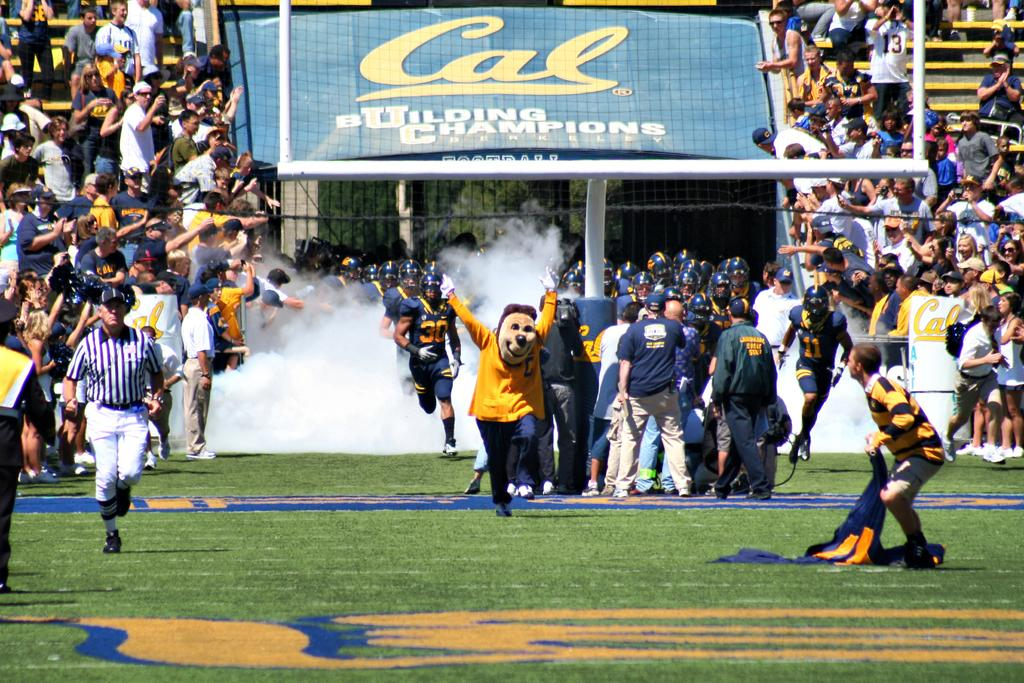Provide a one-sentence caption for the provided image. Football stadium that has a blue sign saying "Cal". 